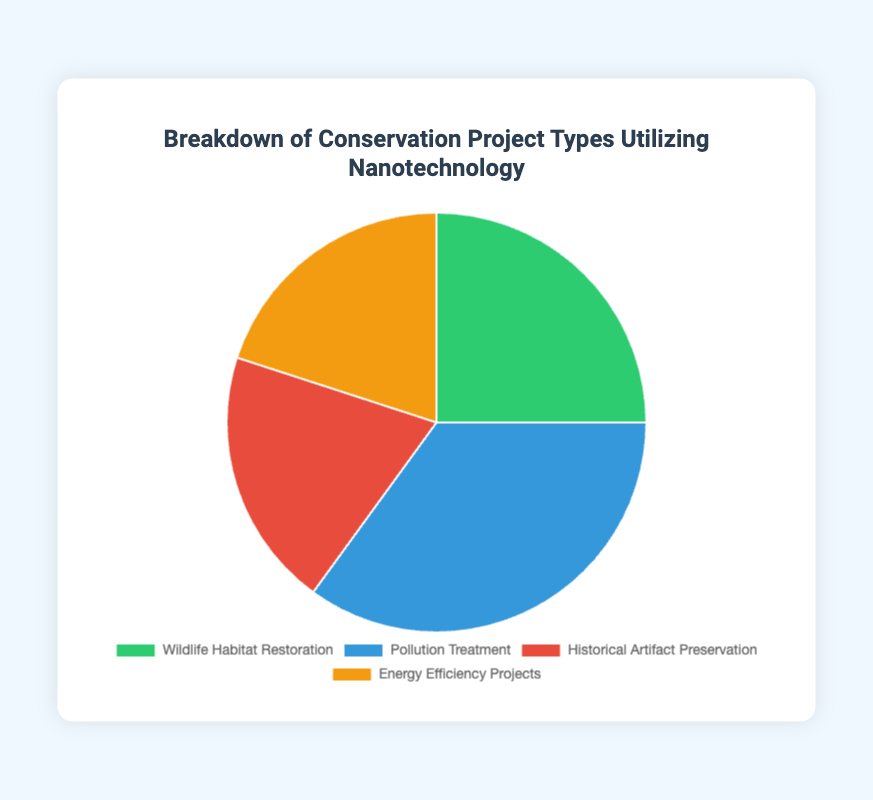What percentage of conservation projects utilizing nanotechnology is dedicated to Wildlife Habitat Restoration? Refer to the pie chart and look for the segment labeled "Wildlife Habitat Restoration". This segment shows 25%, indicating that 25% of the conservation projects are dedicated to Wildlife Habitat Restoration.
Answer: 25% What is the combined percentage of Historical Artifact Preservation and Energy Efficiency Projects? Add the percentage values for Historical Artifact Preservation (20%) and Energy Efficiency Projects (20%). The combined percentage is 20% + 20% = 40%.
Answer: 40% Which project type uses the highest percentage of nanotechnology in conservation projects? Look at the pie chart and identify the segment with the largest percentage. The "Pollution Treatment" segment has the highest value at 35%.
Answer: Pollution Treatment What is the difference in usage percentage between Wildlife Habitat Restoration and Pollution Treatment? Subtract the percentage of Wildlife Habitat Restoration (25%) from the percentage of Pollution Treatment (35%). The difference is 35% - 25% = 10%.
Answer: 10% Which project types have an equal usage percentage of nanotechnology in conservation projects? Look for segments in the pie chart with the same percentage values and identify them. Both Historical Artifact Preservation and Energy Efficiency Projects have equal values of 20%.
Answer: Historical Artifact Preservation and Energy Efficiency Projects Which project type is represented by the green segment in the pie chart? Identify the color associated with each segment in the chart. The green segment correlates with "Wildlife Habitat Restoration".
Answer: Wildlife Habitat Restoration Out of the four project types, which has the smallest usage percentage of nanotechnology? Compare all the segments in the pie chart and find the smallest percentage. Both Historical Artifact Preservation and Energy Efficiency Projects are the smallest with 20% each.
Answer: Historical Artifact Preservation and Energy Efficiency Projects How much larger is the usage percentage for Pollution Treatment compared to Energy Efficiency Projects? Subtract the percentage of Energy Efficiency Projects (20%) from the percentage of Pollution Treatment (35%). The difference is 35% - 20% = 15%.
Answer: 15% 